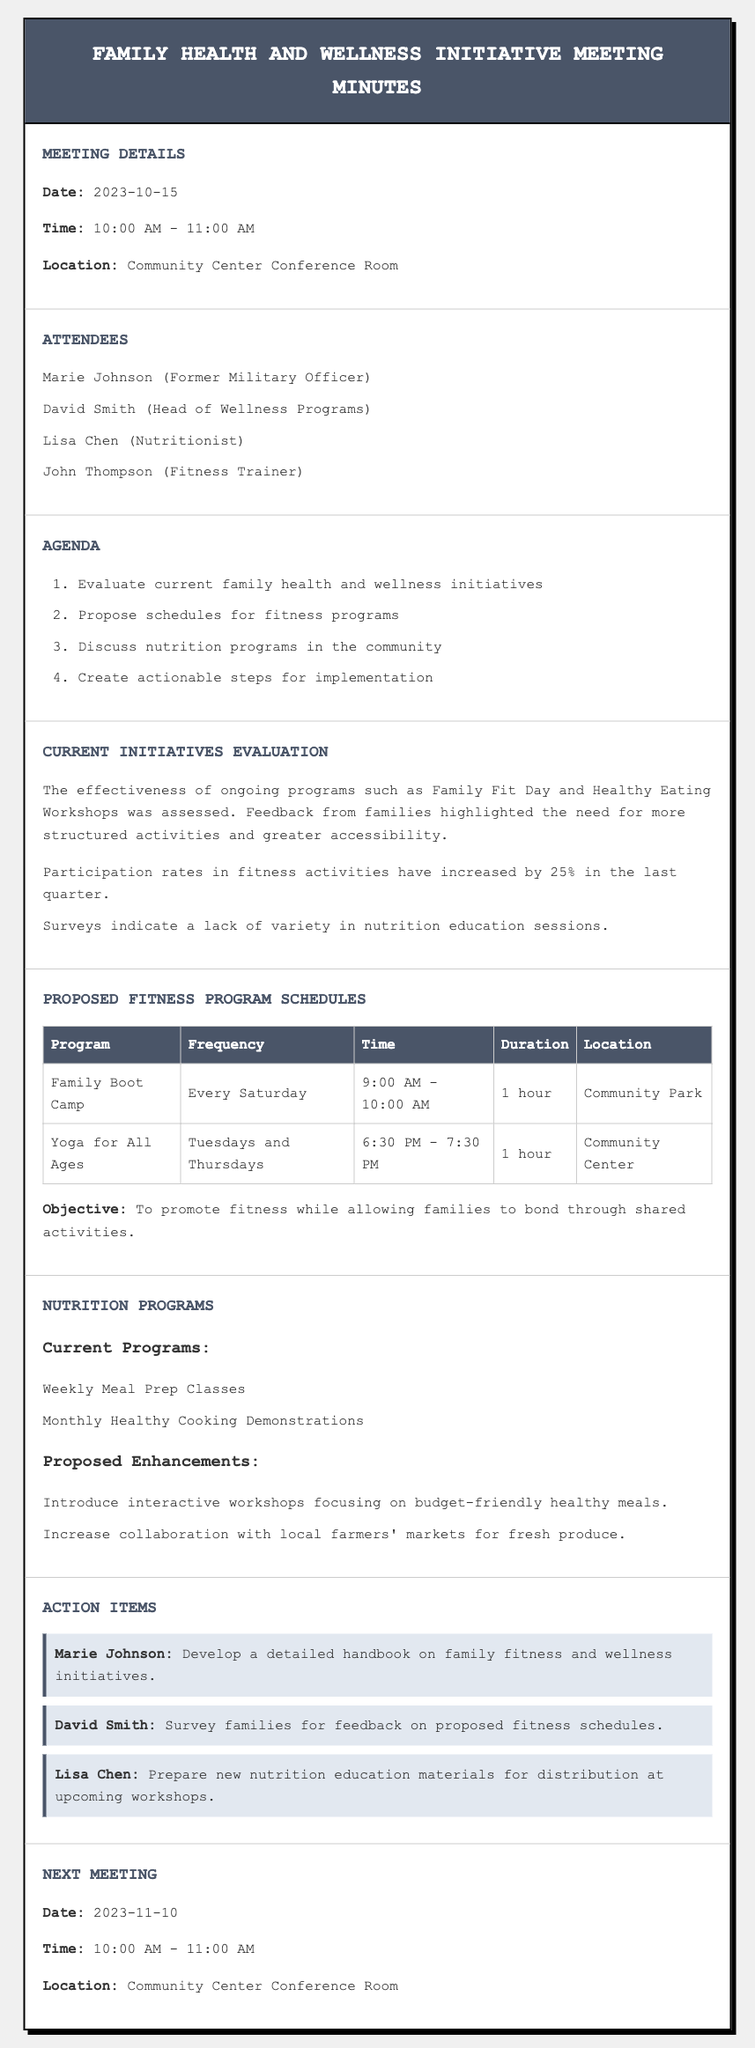what is the date of the meeting? The meeting date is listed in the document under Meeting Details as when the meeting took place.
Answer: 2023-10-15 who is the head of wellness programs? The document includes a section on Attendees, where the head of wellness programs is mentioned by name.
Answer: David Smith how many fitness programs are proposed in the document? The proposed fitness program schedules section contains a table with specific programs listed in it.
Answer: 2 what is the time for the Family Boot Camp program? The time for Family Boot Camp is provided in the Proposed Fitness Program Schedules table for the specific program.
Answer: 9:00 AM - 10:00 AM which nutrition program involves monthly cooking demonstrations? The Current Programs section details two nutrition programs, one of which is described as a monthly event.
Answer: Monthly Healthy Cooking Demonstrations what action item is assigned to Marie Johnson? The Action Items section specifies tasks assigned to different individuals, including Marie Johnson's responsibility.
Answer: Develop a detailed handbook on family fitness and wellness initiatives what is the objective of the proposed fitness programs? The document states the objective related to fitness programs, reflecting the purpose behind them.
Answer: To promote fitness while allowing families to bond through shared activities when is the next scheduled meeting? The Next Meeting section gives the date when the following meeting will take place, which is explicitly stated.
Answer: 2023-11-10 which location is consistently used for meetings? The document mentions a location for both the current and next meeting, highlighting its repeated use.
Answer: Community Center Conference Room 